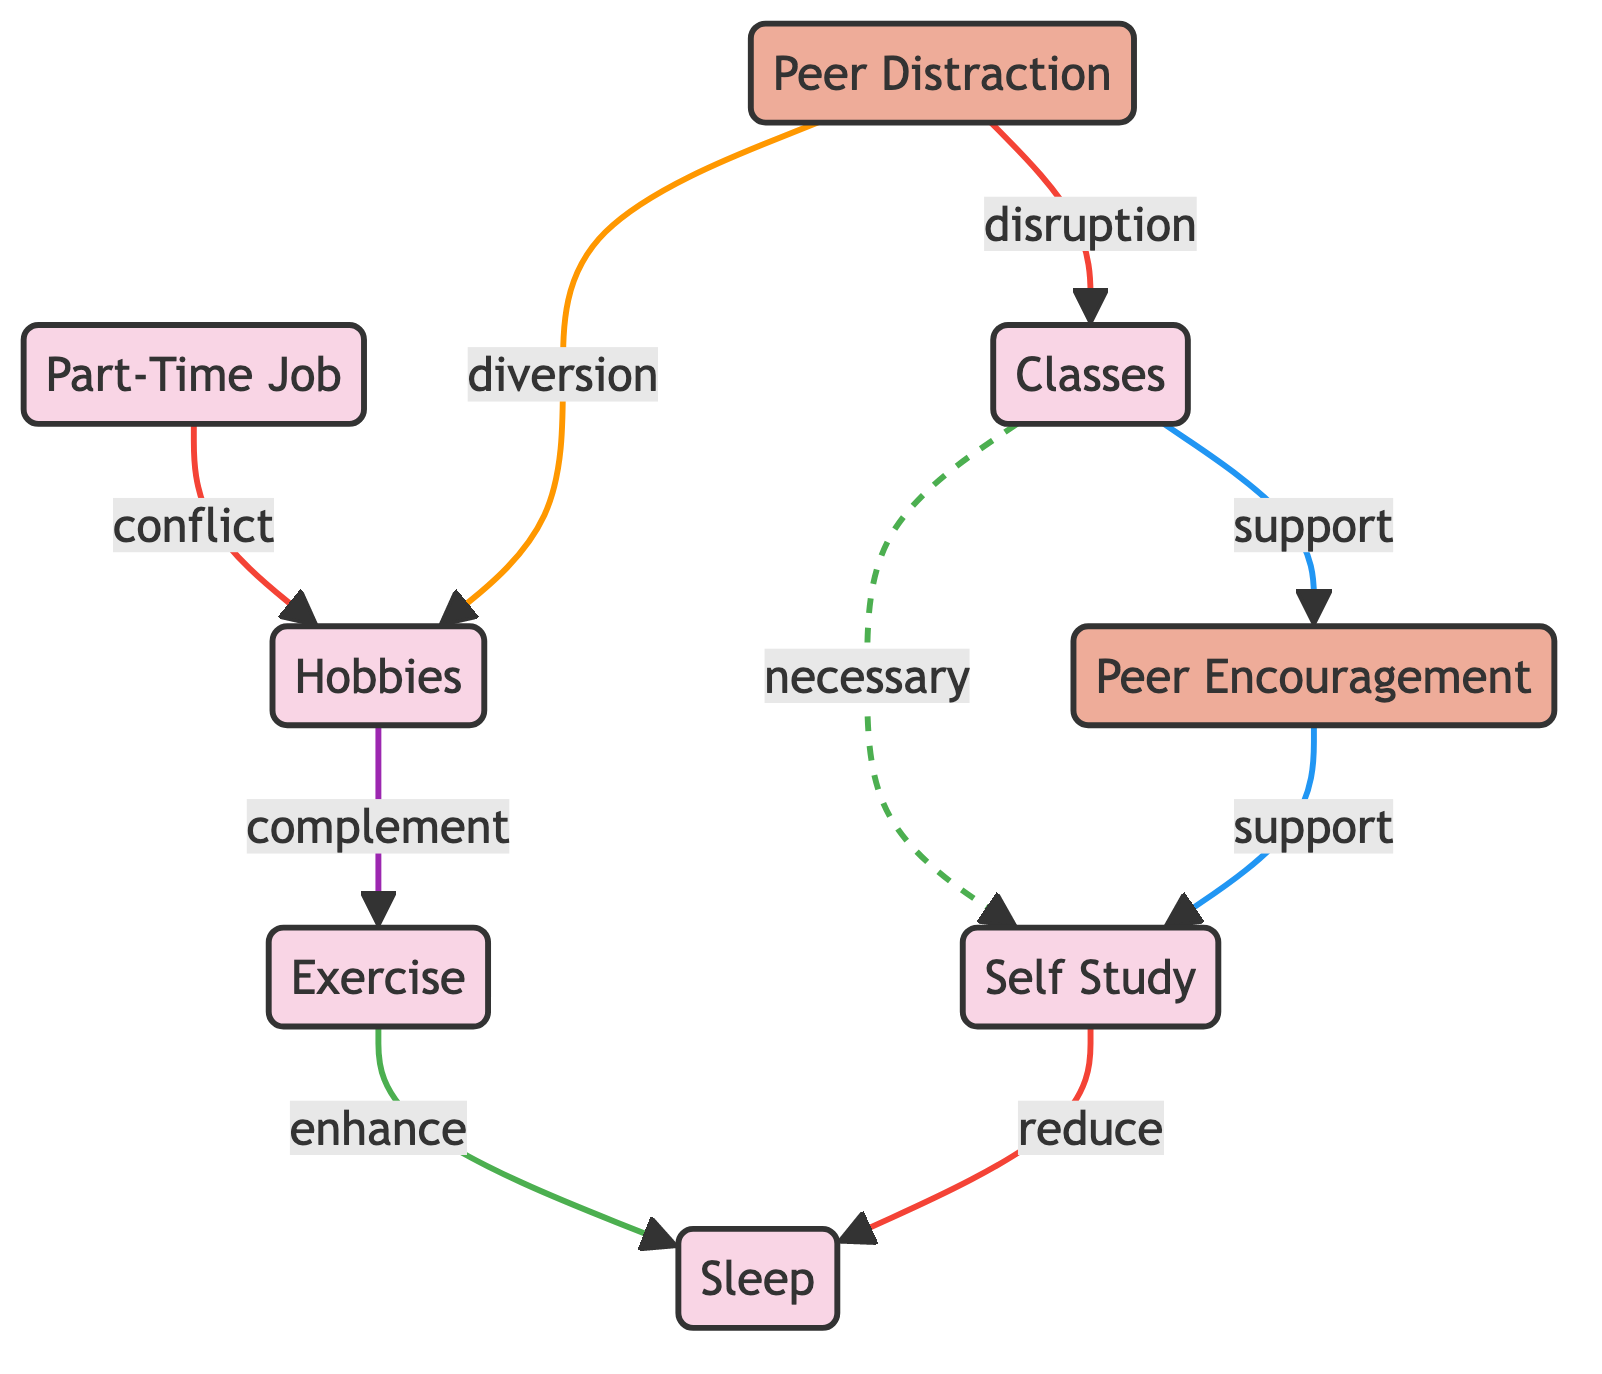What's the total number of nodes in the diagram? The diagram contains a list of nodes. By counting each unique element in the "nodes" section of the data, we find 8 nodes: Classes, Hobbies, Part-Time Job, Peer Encouragement, Peer Distraction, Self Study, Exercise, and Sleep.
Answer: 8 What type of relationship exists between Classes and Self Study? In the diagram, the edge connecting Classes to Self Study is labeled "necessary," indicating that Self Study is a mandatory activity that follows from attending Classes.
Answer: necessary Which activity is impacted by both Peer Distraction and Part-Time Job? Peer Distraction affects Hobbies through diversion, and the Part-Time Job creates a conflict with Hobbies. Thus, both influences affect the Hobbies activity directly.
Answer: Hobbies How many edges are there in total in the diagram? The edges represent relationships between nodes, and by counting them in the "edges" section of the data, we find there are a total of 9 edges connecting the activities and influences.
Answer: 9 What is the relationship between Exercise and Sleep? The edge between Exercise and Sleep is labeled "enhance," indicating that engaging in Exercise improves or contributes positively to the quality or duration of Sleep.
Answer: enhance How do Peer Encouragement and Peer Distraction relate to Self Study and Classes? Peer Encouragement supports Self Study, while Peer Distraction disrupts both Classes and Hobbies. This shows that Peer Distraction can negatively impact the ability to focus on Classwork and study independently.
Answer: support and disruption Which activity complements Hobbies according to the diagram? The edge connecting Hobbies to Exercise is labeled "complement," meaning that Hobbies and Exercise support each other functionally or positively in a way that they enhance one another's benefits.
Answer: Exercise What type of influence is Peer Distraction classified as? According to the node type in the diagram, Peer Distraction is classified as an influence, specifically affecting other activities through disruption and diversion.
Answer: influence How does Self Study impact Sleep according to the diagram? The relationship between Self Study and Sleep is labeled "reduce," indicating that engaging in Self Study can have a diminishing effect on the amount of Sleep one gets.
Answer: reduce 